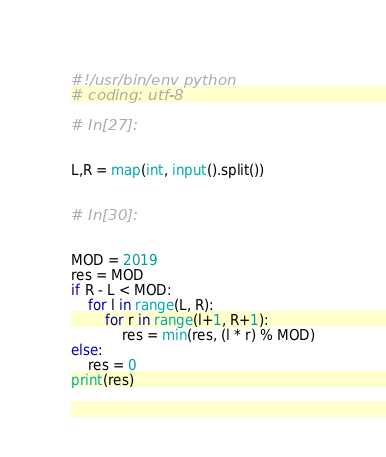<code> <loc_0><loc_0><loc_500><loc_500><_Python_>#!/usr/bin/env python
# coding: utf-8

# In[27]:


L,R = map(int, input().split())


# In[30]:


MOD = 2019
res = MOD
if R - L < MOD:
    for l in range(L, R):
        for r in range(l+1, R+1):
            res = min(res, (l * r) % MOD)
else:
    res = 0
print(res)

</code> 